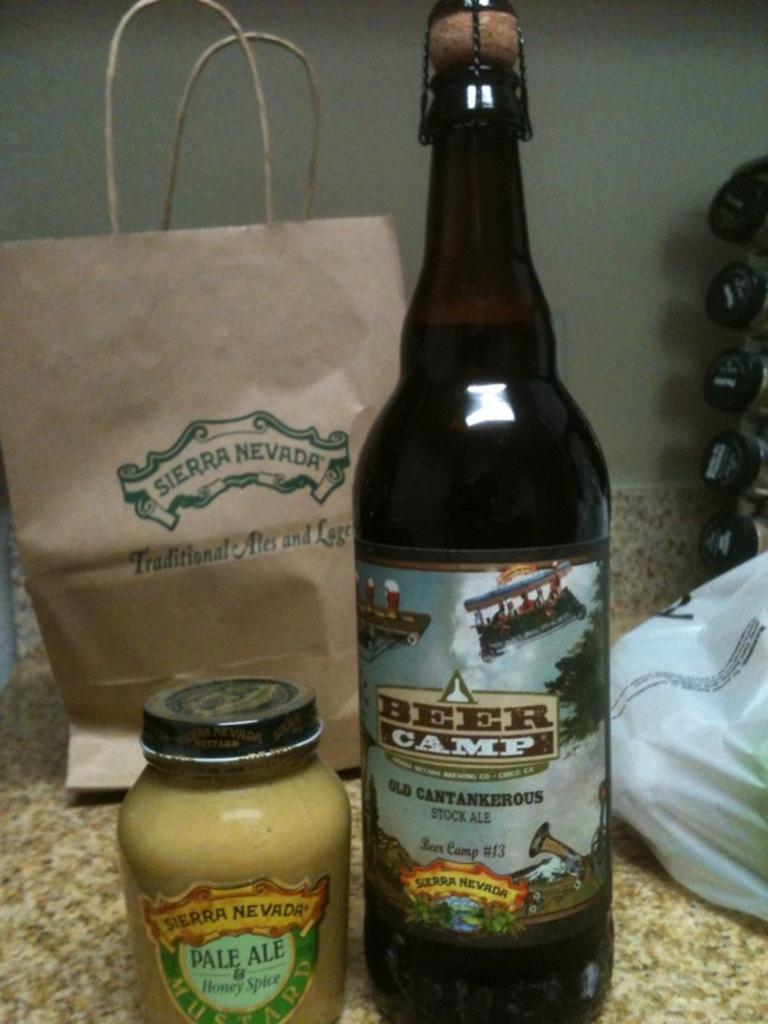<image>
Summarize the visual content of the image. Among the items procured from Sierra Nevada: Pale Ale honey spice and Beer Camp stock ale. 